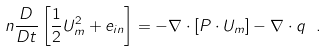<formula> <loc_0><loc_0><loc_500><loc_500>n \frac { D } { D t } \left [ \frac { 1 } { 2 } U _ { m } ^ { 2 } + e _ { i n } \right ] = - \nabla \cdot \left [ P \cdot U _ { m } \right ] - \nabla \cdot q \ .</formula> 